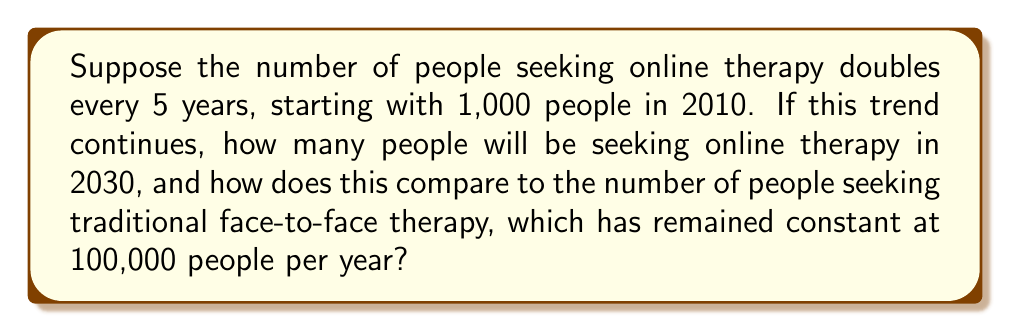What is the answer to this math problem? 1) First, let's calculate the number of people seeking online therapy in 2030:
   - 2010 to 2030 is a span of 20 years
   - The number doubles every 5 years, so it will double 4 times (20 ÷ 5 = 4)
   - We can represent this as: $1000 \times 2^4$

2) Calculate $2^4$:
   $2^4 = 2 \times 2 \times 2 \times 2 = 16$

3) Multiply by the initial number:
   $1000 \times 16 = 16,000$

4) Compare to face-to-face therapy:
   - Online therapy in 2030: 16,000
   - Face-to-face therapy: 100,000

5) Calculate the percentage:
   $\frac{16,000}{100,000} \times 100 = 16\%$

Therefore, in 2030, the number of people seeking online therapy will be 16% of those seeking face-to-face therapy.

6) To express the exponential growth mathematically:
   $N(t) = 1000 \times 2^{\frac{t}{5}}$
   Where $N(t)$ is the number of people seeking online therapy and $t$ is the number of years since 2010.
Answer: 16,000 people; 16% of face-to-face therapy numbers 